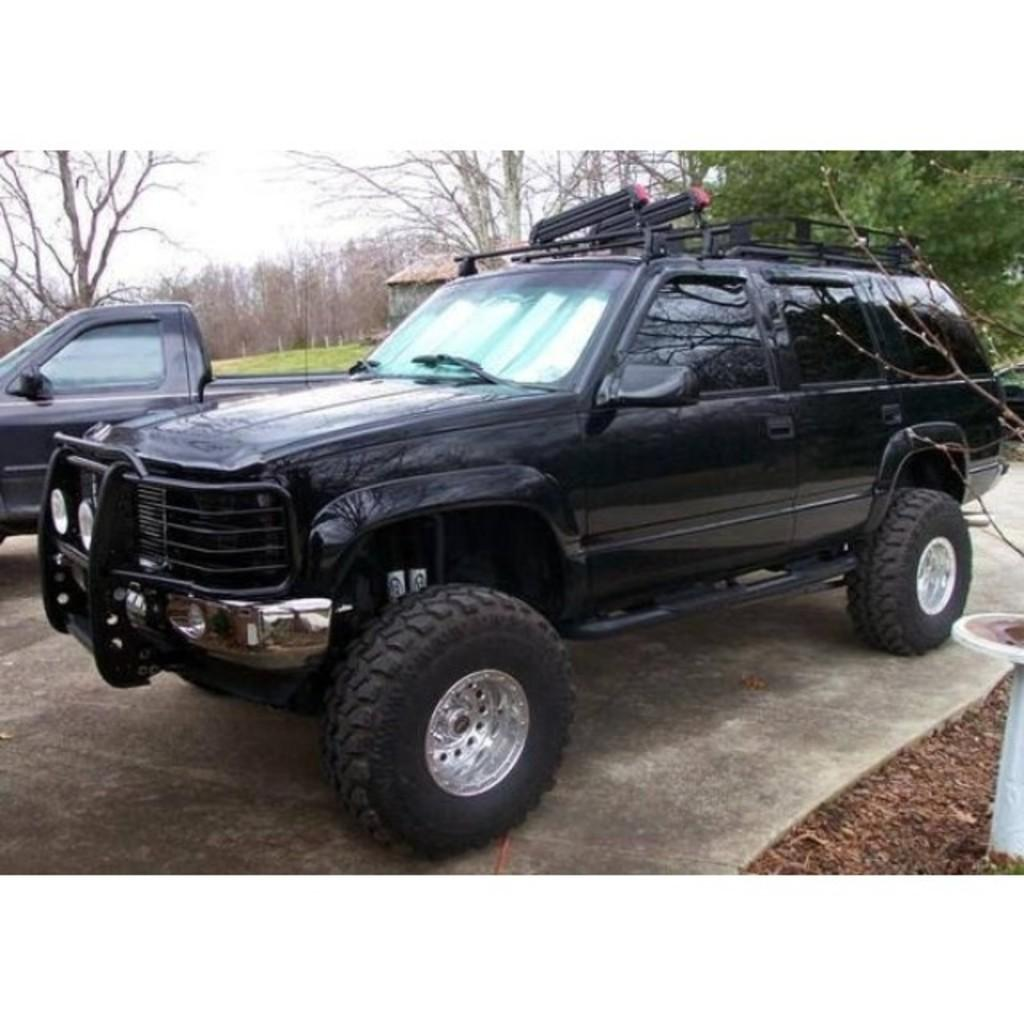What types of vehicles are in the image? There are vehicles in the image, but the specific types cannot be determined from the provided facts. What can be seen in the background of the image? There are trees and the sky visible in the background of the image. What type of structure is present in the image? There is a shed in the image. What type of pan is being used to cook food in the image? There is no pan or cooking activity present in the image. How does the image demonstrate respect for the environment? The image itself does not demonstrate respect for the environment; it only shows vehicles, trees, a shed, and the sky. 